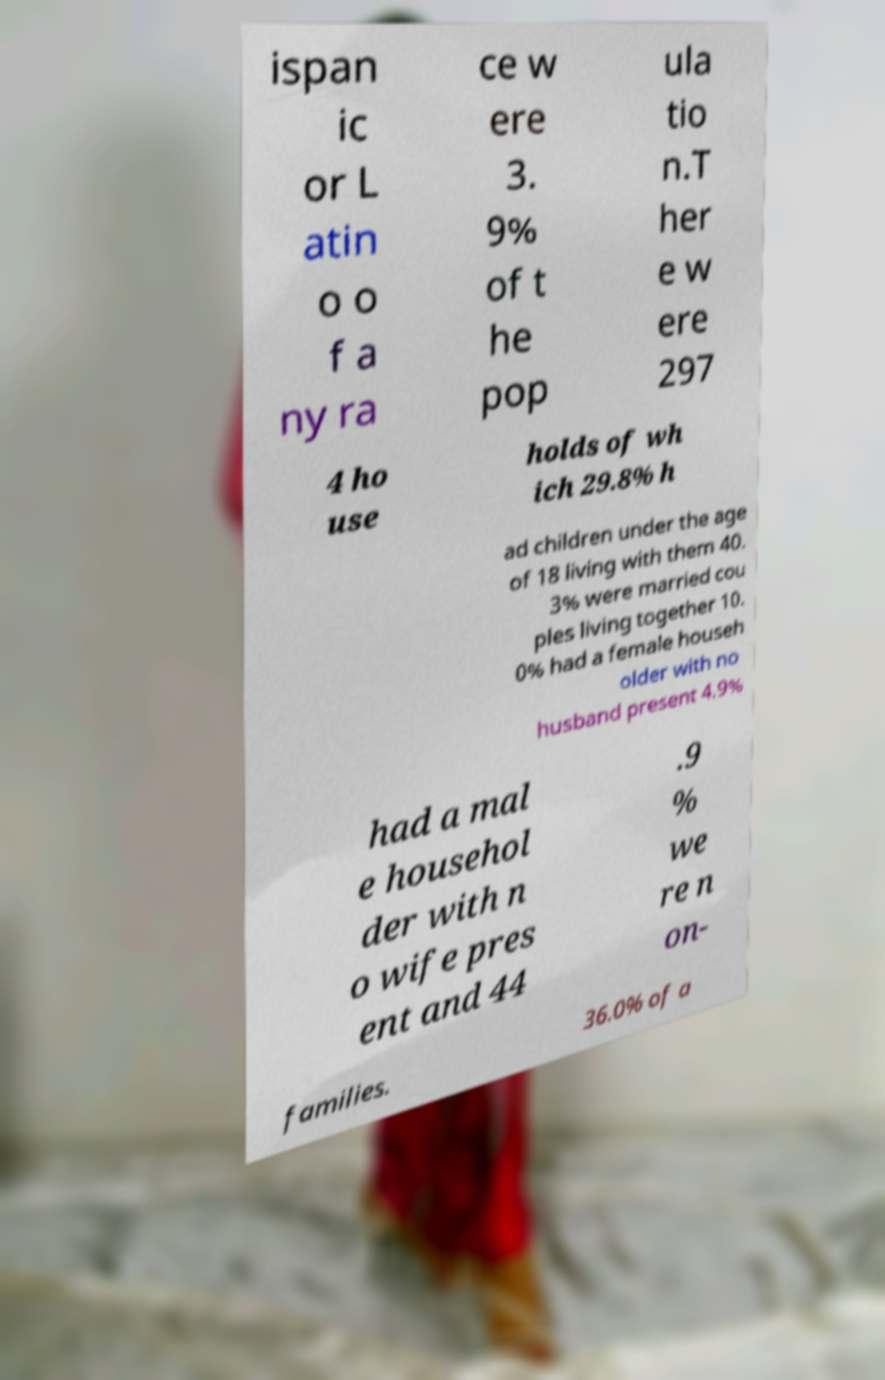Could you extract and type out the text from this image? ispan ic or L atin o o f a ny ra ce w ere 3. 9% of t he pop ula tio n.T her e w ere 297 4 ho use holds of wh ich 29.8% h ad children under the age of 18 living with them 40. 3% were married cou ples living together 10. 0% had a female househ older with no husband present 4.9% had a mal e househol der with n o wife pres ent and 44 .9 % we re n on- families. 36.0% of a 